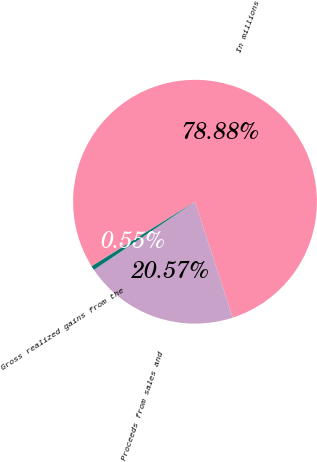Convert chart. <chart><loc_0><loc_0><loc_500><loc_500><pie_chart><fcel>In millions<fcel>Proceeds from sales and<fcel>Gross realized gains from the<nl><fcel>78.88%<fcel>20.57%<fcel>0.55%<nl></chart> 